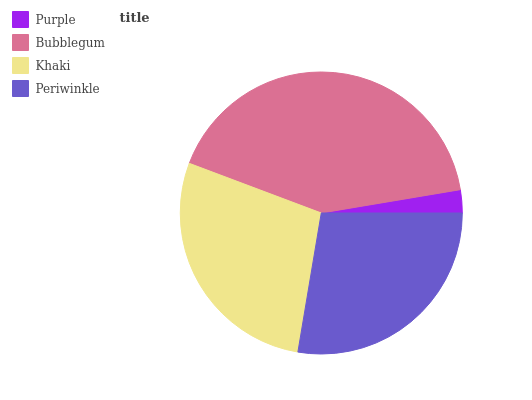Is Purple the minimum?
Answer yes or no. Yes. Is Bubblegum the maximum?
Answer yes or no. Yes. Is Khaki the minimum?
Answer yes or no. No. Is Khaki the maximum?
Answer yes or no. No. Is Bubblegum greater than Khaki?
Answer yes or no. Yes. Is Khaki less than Bubblegum?
Answer yes or no. Yes. Is Khaki greater than Bubblegum?
Answer yes or no. No. Is Bubblegum less than Khaki?
Answer yes or no. No. Is Khaki the high median?
Answer yes or no. Yes. Is Periwinkle the low median?
Answer yes or no. Yes. Is Periwinkle the high median?
Answer yes or no. No. Is Bubblegum the low median?
Answer yes or no. No. 